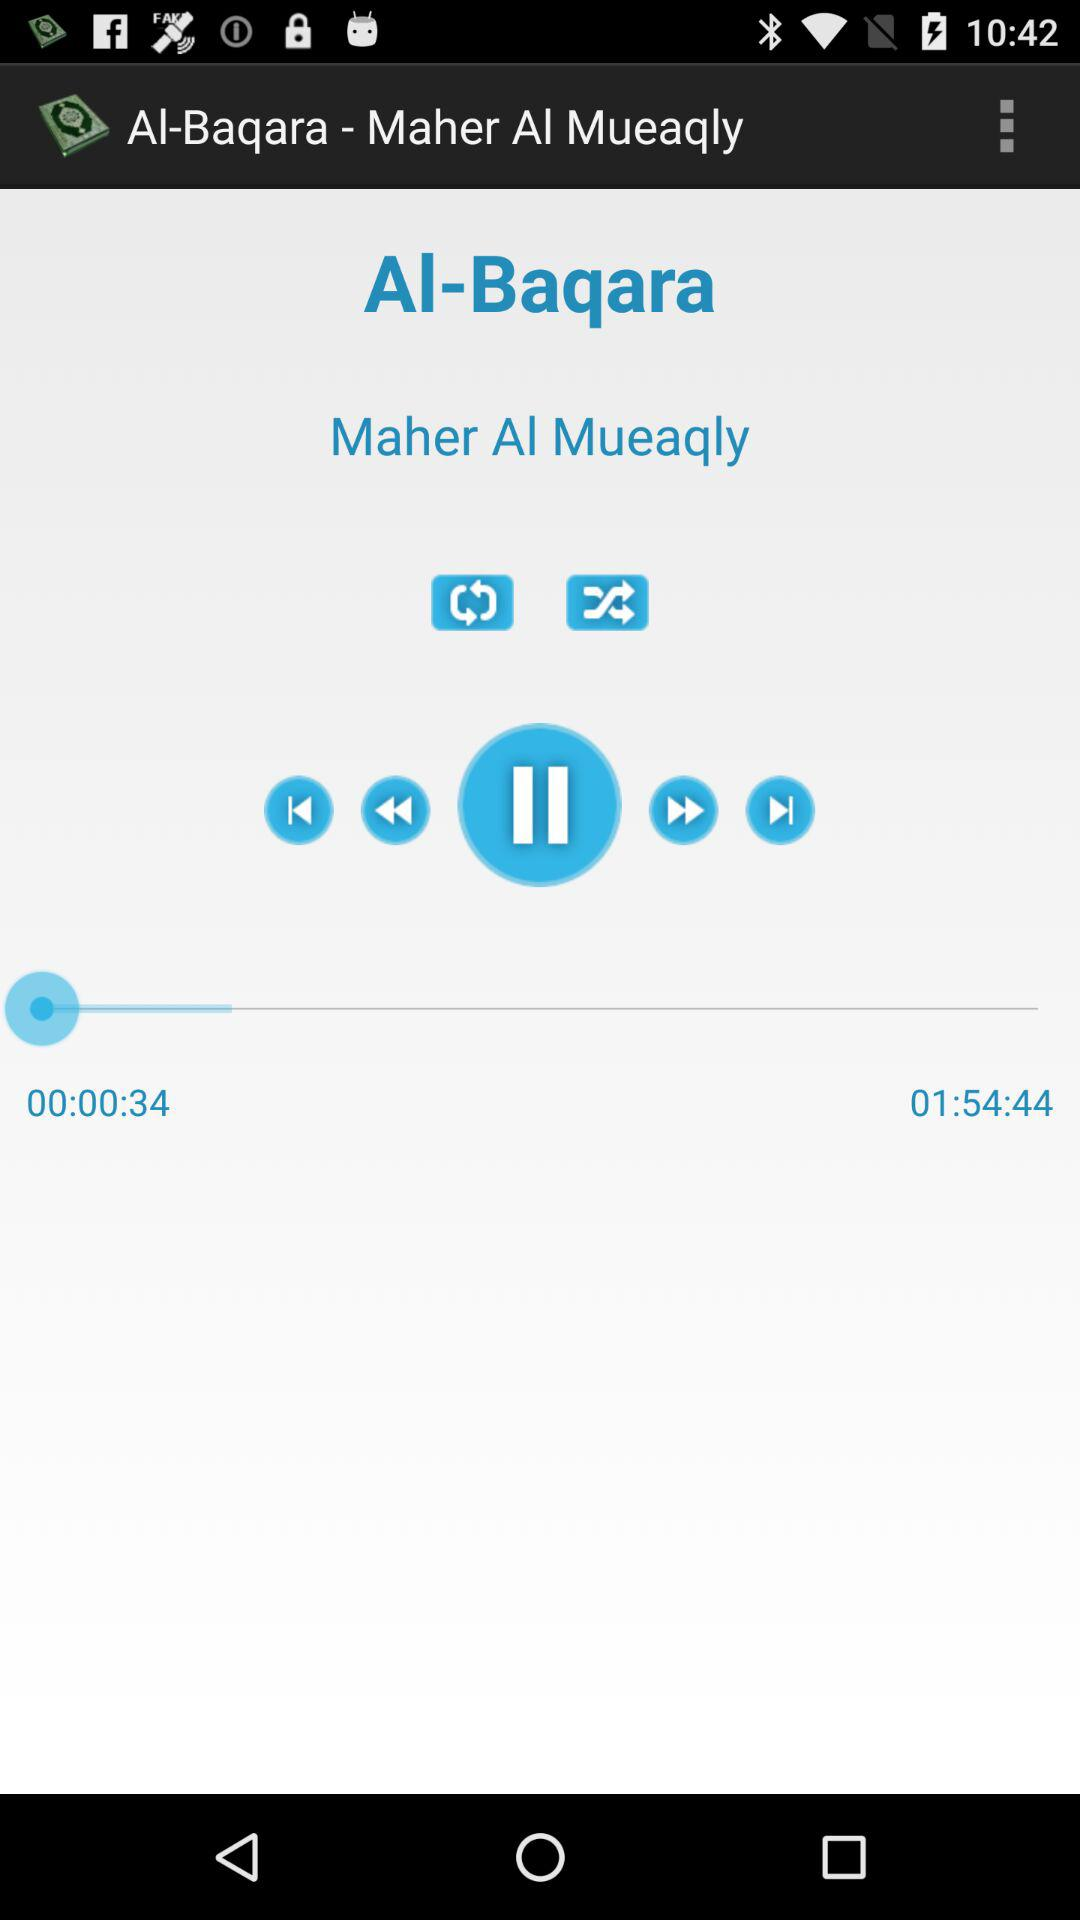Who is the singer of the song "Al-Baqara"? The singer of the song "Al-Baqara" is Maher Al Mueaqly. 